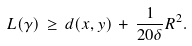Convert formula to latex. <formula><loc_0><loc_0><loc_500><loc_500>L ( \gamma ) \, \geq \, d ( x , y ) \, + \, \frac { 1 } { 2 0 \delta } R ^ { 2 } .</formula> 